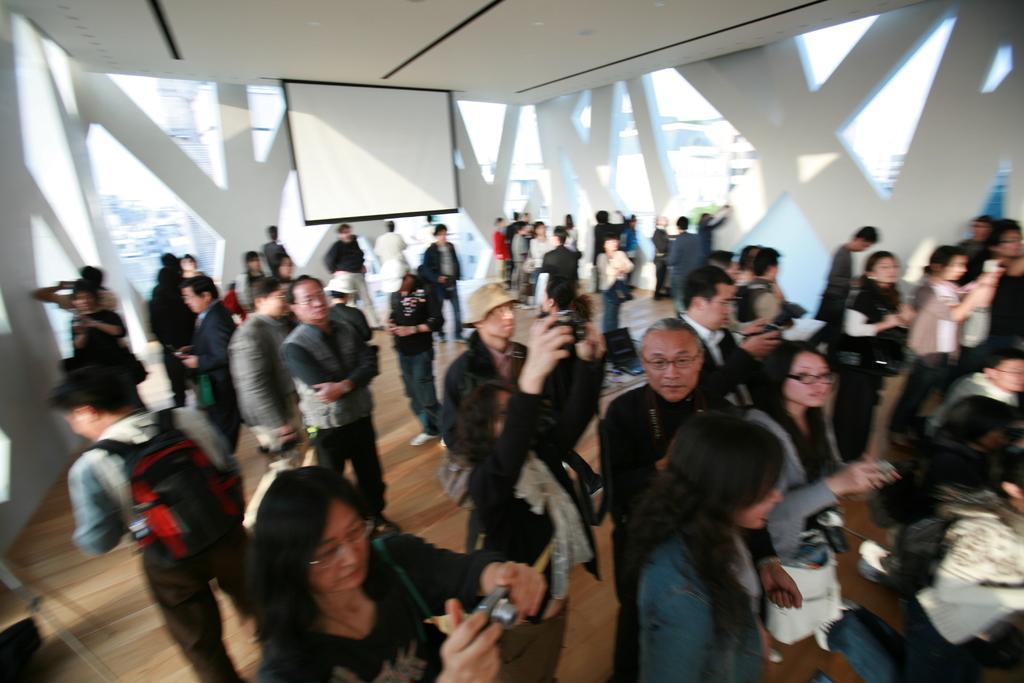Describe this image in one or two sentences. Here we can see few people are standing on the floor and among them few are carrying cameras in their hands. In the background we can see a screen,lights on the ceiling and glass doors. Through the glass doors we can see buildings and sky. 